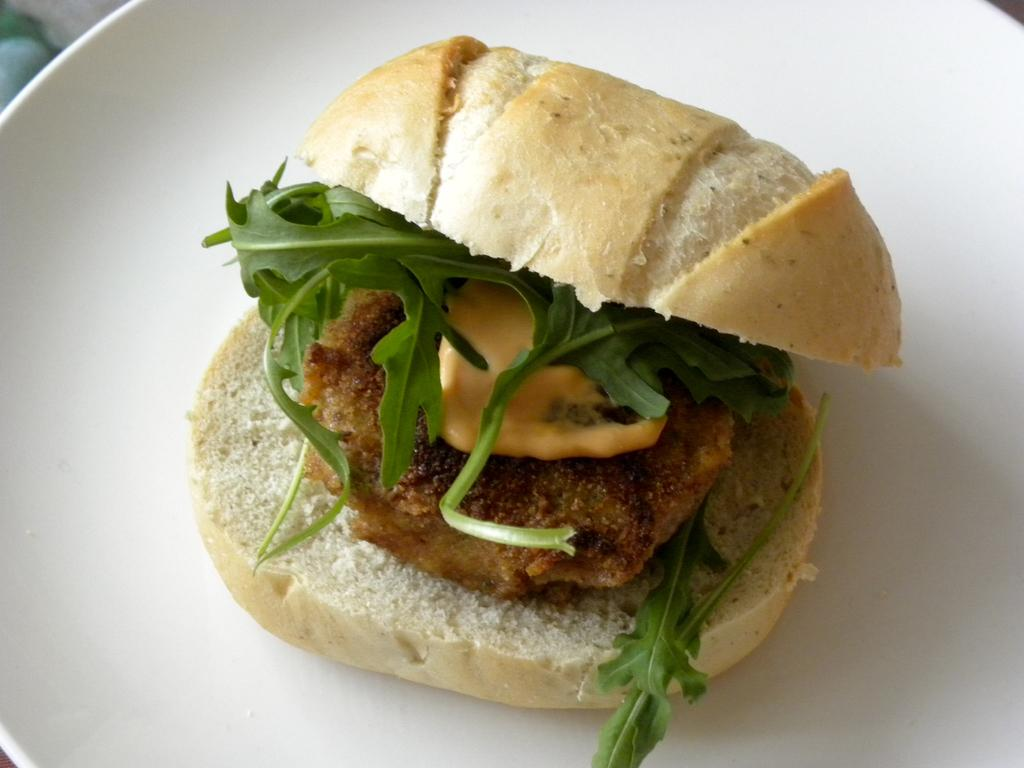What is the color of the platter in the image? The platter in the image is white. What type of food item is on the platter? The platter contains a food item that resembles a burger. What type of garnish is visible on the platter? There are coriander leaves visible on the platter. Are there any other food items on the platter besides the burger? Yes, there are other food items on the platter. What hobbies does the girl on the platter enjoy? There is no girl present on the platter; it contains food items. How many wings are visible on the platter? There are no wings visible on the platter; it contains a burger and other food items. 